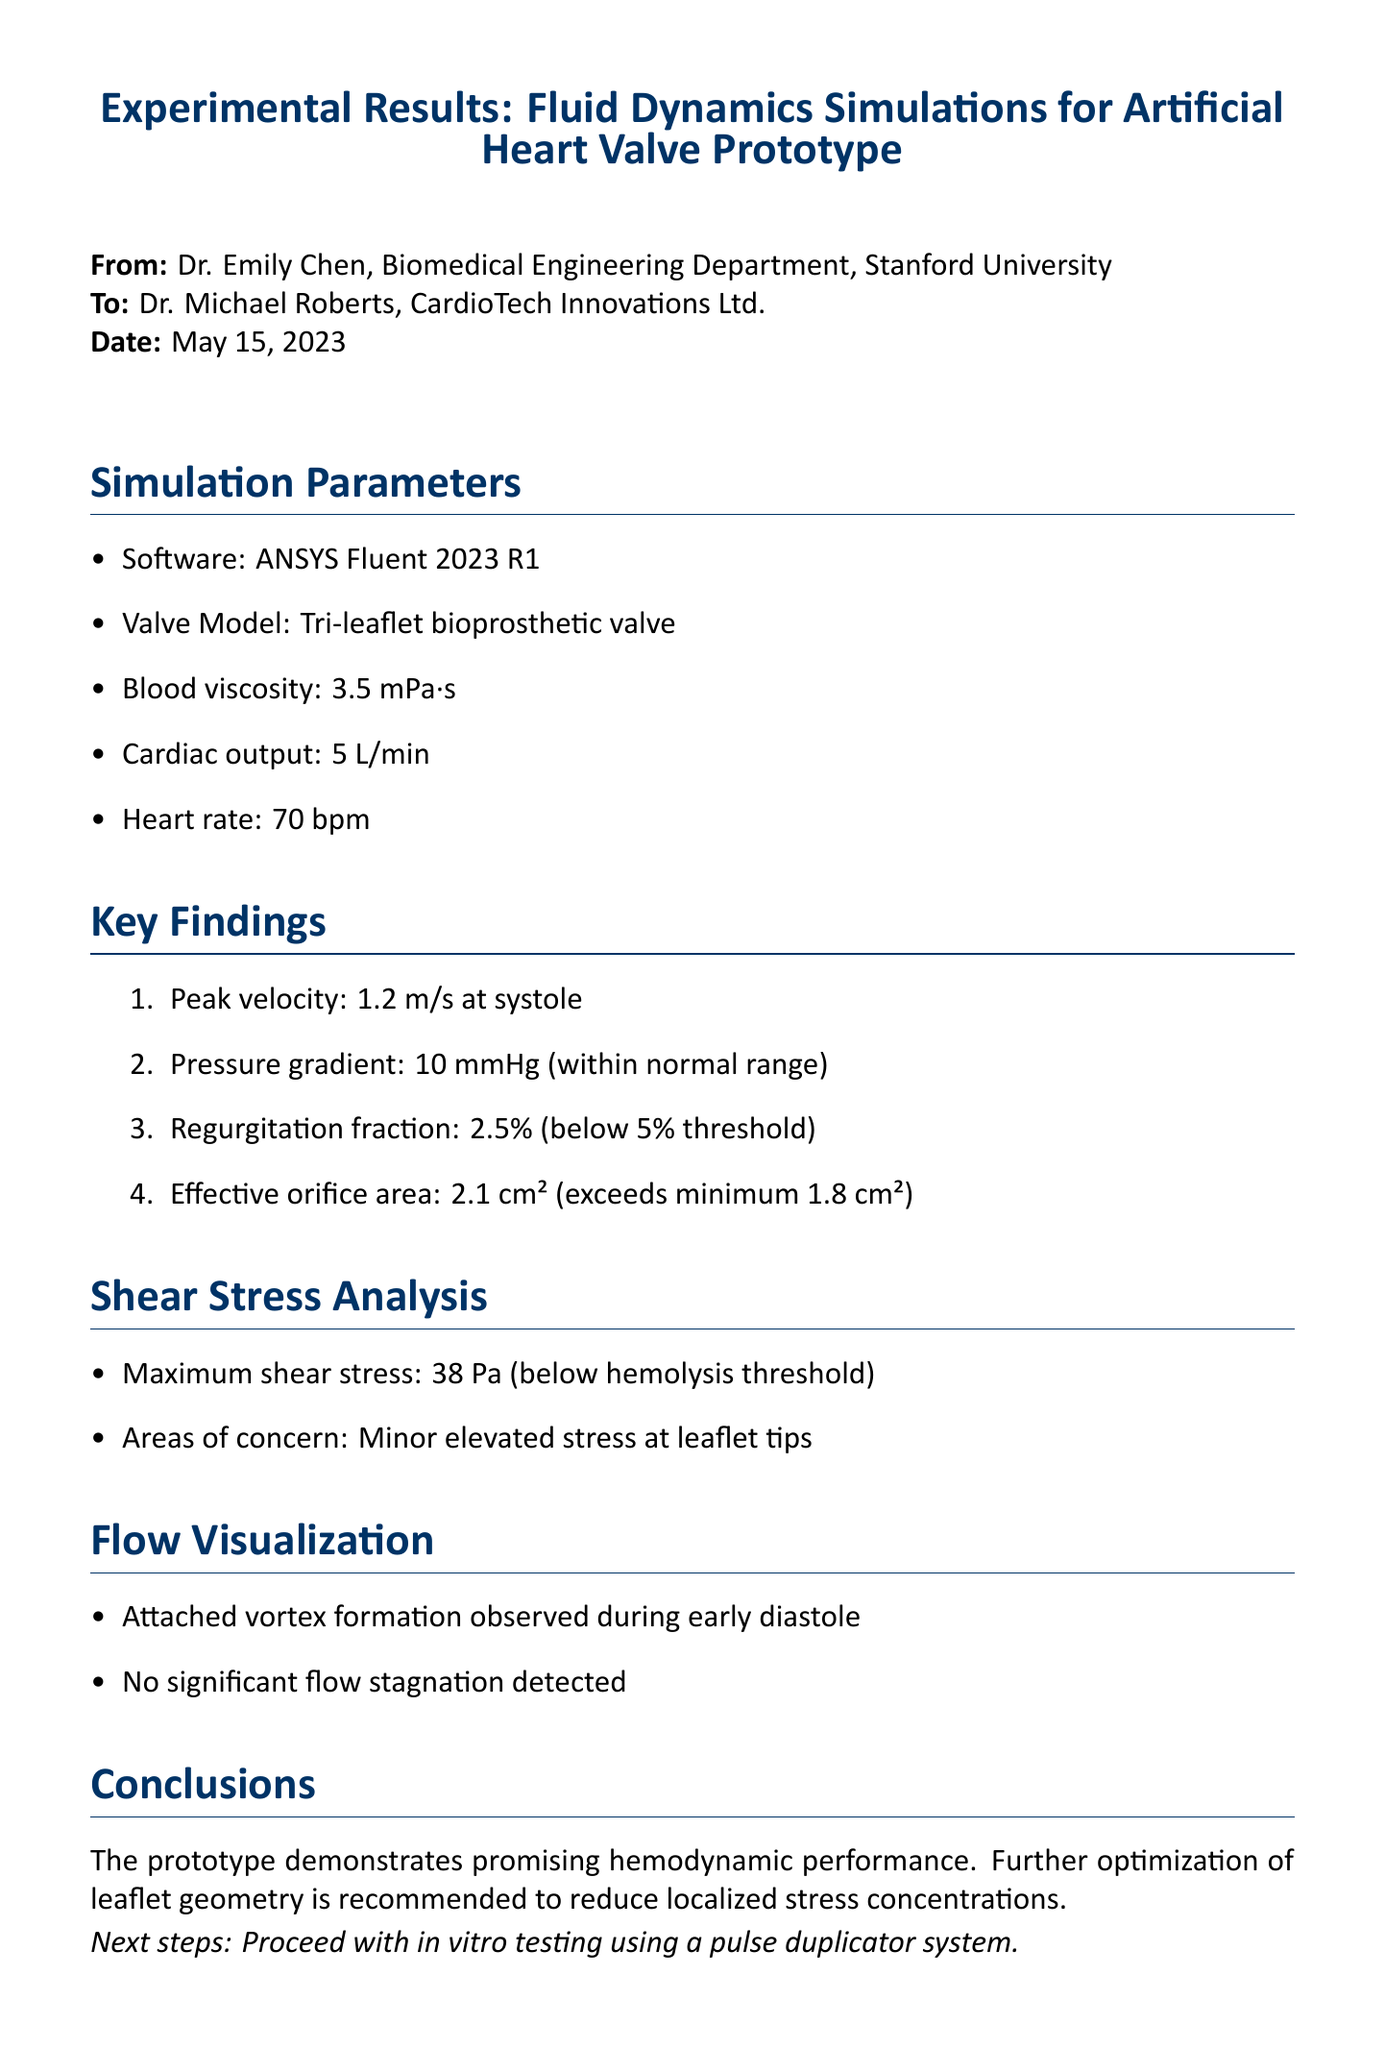What is the peak velocity observed? The peak velocity is noted as the highest speed of blood flow during systole, measured at 1.2 m/s.
Answer: 1.2 m/s What is the regurgitation fraction reported? The regurgitation fraction indicates the percentage of blood that returns to the heart rather than moving forward, which is stated as 2.5%.
Answer: 2.5% What is the effective orifice area? The effective orifice area represents the size of the opening through which blood flows, recorded as 2.1 cm².
Answer: 2.1 cm² What software was used for the simulations? The software employed for the fluid dynamics simulations is specified in the document as ANSYS Fluent 2023 R1.
Answer: ANSYS Fluent 2023 R1 What action is recommended for the prototype? The document suggests to further optimize the leaflet geometry to mitigate localized stress concentrations observed in the analysis.
Answer: Optimize leaflet geometry What is the maximum shear stress reported? The maximum shear stress indicates the highest stress encountered by the blood flow, which is documented as 38 Pa.
Answer: 38 Pa What is the blood viscosity level used in the simulation? Blood viscosity is a critical parameter affecting fluid dynamics, with a stated level of 3.5 mPa·s used in this study.
Answer: 3.5 mPa·s What is the pressure gradient found in the simulation? The pressure gradient reveals the change in pressure throughout the valve, reported as 10 mmHg.
Answer: 10 mmHg What areas showed minor elevated stress? The specific regions that displayed elevated stress levels are indicated as the leaflet tips during the shear stress analysis.
Answer: Leaflet tips 